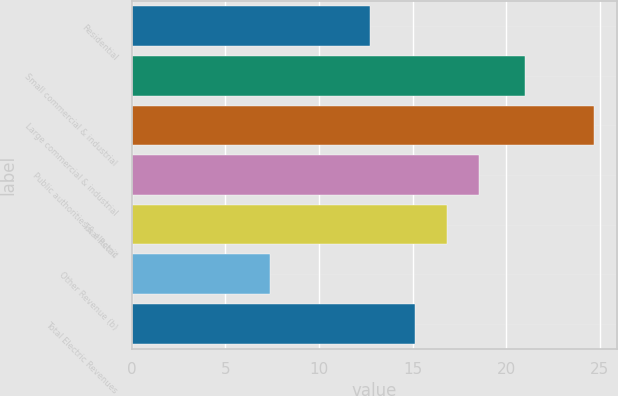<chart> <loc_0><loc_0><loc_500><loc_500><bar_chart><fcel>Residential<fcel>Small commercial & industrial<fcel>Large commercial & industrial<fcel>Public authorities & electric<fcel>Total Retail<fcel>Other Revenue (b)<fcel>Total Electric Revenues<nl><fcel>12.7<fcel>21<fcel>24.7<fcel>18.56<fcel>16.83<fcel>7.4<fcel>15.1<nl></chart> 